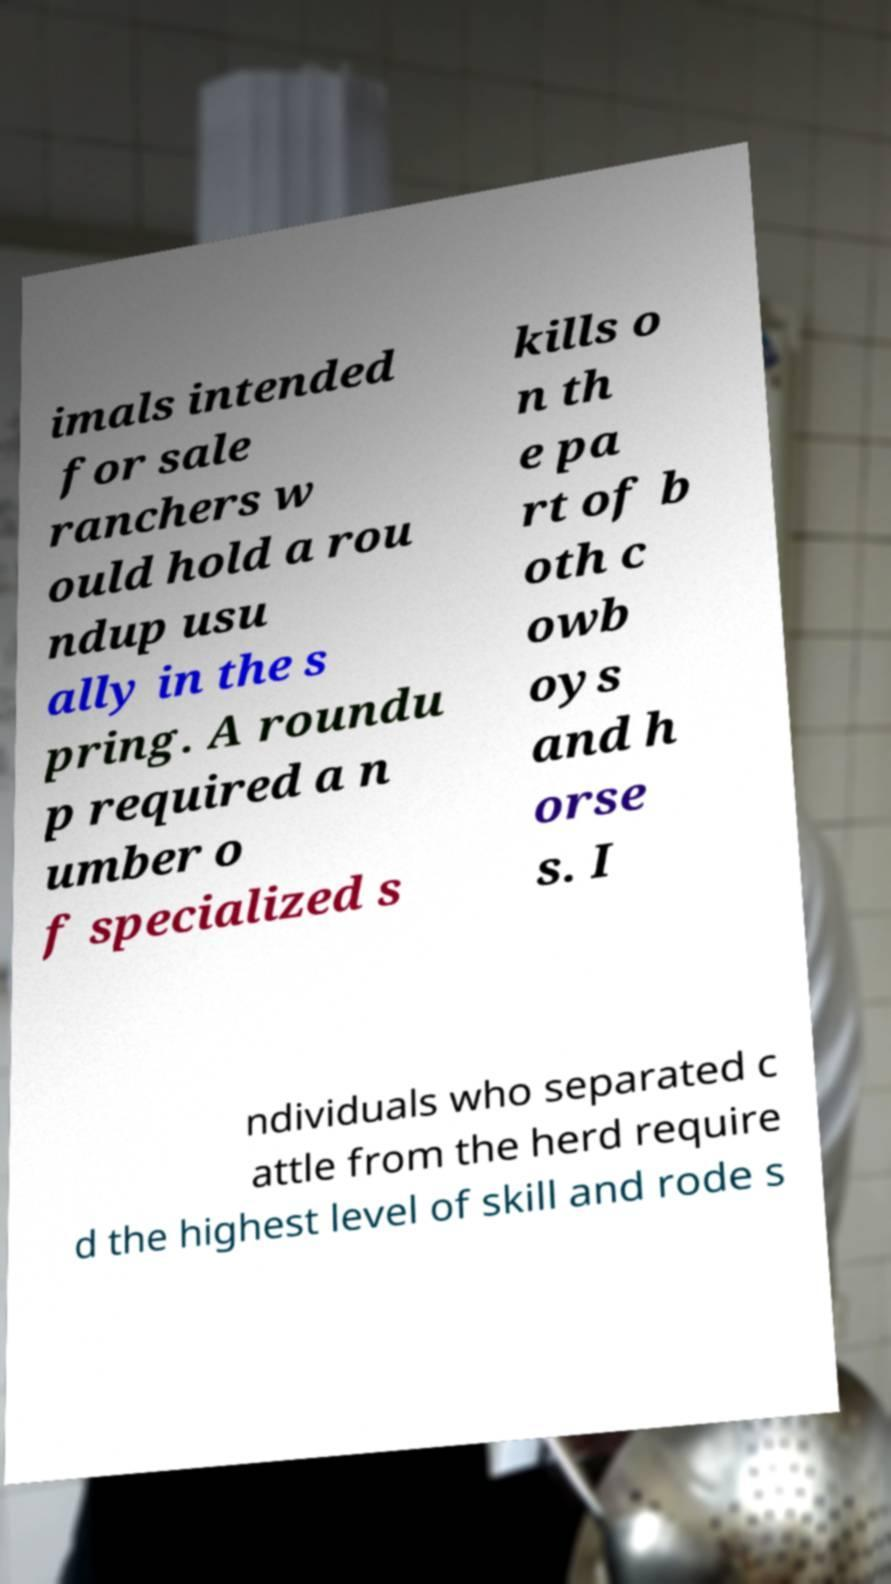Can you read and provide the text displayed in the image?This photo seems to have some interesting text. Can you extract and type it out for me? imals intended for sale ranchers w ould hold a rou ndup usu ally in the s pring. A roundu p required a n umber o f specialized s kills o n th e pa rt of b oth c owb oys and h orse s. I ndividuals who separated c attle from the herd require d the highest level of skill and rode s 